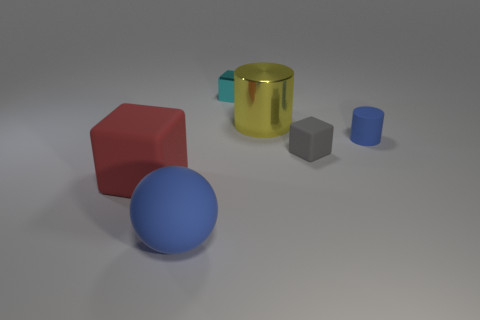Add 1 rubber balls. How many objects exist? 7 Subtract all cylinders. How many objects are left? 4 Add 4 tiny blue rubber cubes. How many tiny blue rubber cubes exist? 4 Subtract all red cubes. How many cubes are left? 2 Subtract all small gray blocks. How many blocks are left? 2 Subtract 0 yellow balls. How many objects are left? 6 Subtract 2 cylinders. How many cylinders are left? 0 Subtract all purple cubes. Subtract all blue cylinders. How many cubes are left? 3 Subtract all green cylinders. How many red blocks are left? 1 Subtract all blue rubber objects. Subtract all large yellow metallic blocks. How many objects are left? 4 